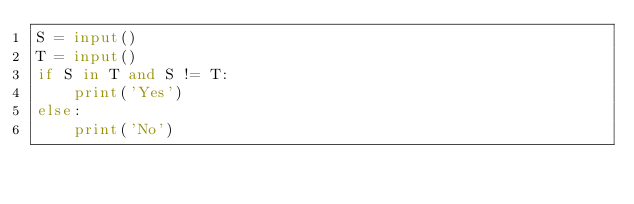<code> <loc_0><loc_0><loc_500><loc_500><_Python_>S = input()
T = input()
if S in T and S != T:
    print('Yes')
else:
    print('No')

</code> 